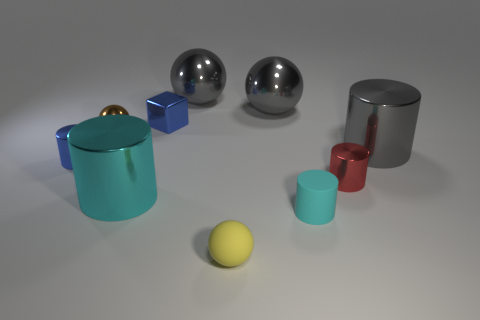What time of day does the lighting in this scene suggest? The lighting in the image seems to be consistent with an indoor setting that has artificial lighting, such as a studio light. It doesn't indicate any particular time of day but rather an environment where the lighting is controlled to highlight the objects equally. 